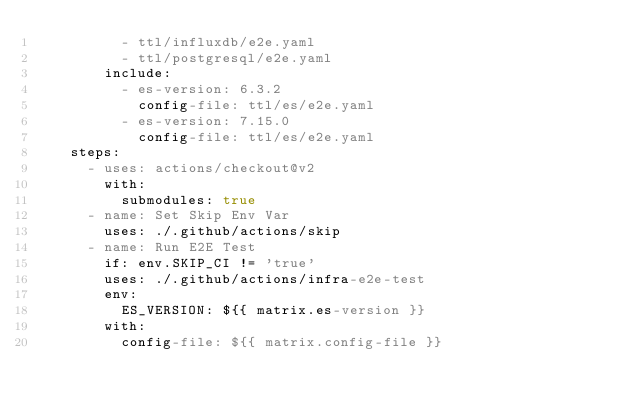Convert code to text. <code><loc_0><loc_0><loc_500><loc_500><_YAML_>          - ttl/influxdb/e2e.yaml
          - ttl/postgresql/e2e.yaml
        include:
          - es-version: 6.3.2
            config-file: ttl/es/e2e.yaml
          - es-version: 7.15.0
            config-file: ttl/es/e2e.yaml
    steps:
      - uses: actions/checkout@v2
        with:
          submodules: true
      - name: Set Skip Env Var
        uses: ./.github/actions/skip
      - name: Run E2E Test
        if: env.SKIP_CI != 'true'
        uses: ./.github/actions/infra-e2e-test
        env:
          ES_VERSION: ${{ matrix.es-version }}
        with:
          config-file: ${{ matrix.config-file }}
</code> 